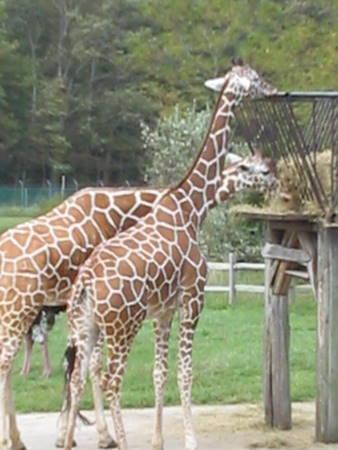Are they tall enough to reach the food?
Concise answer only. Yes. How many animals are here?
Keep it brief. 2. What are the animals eating?
Answer briefly. Hay. 